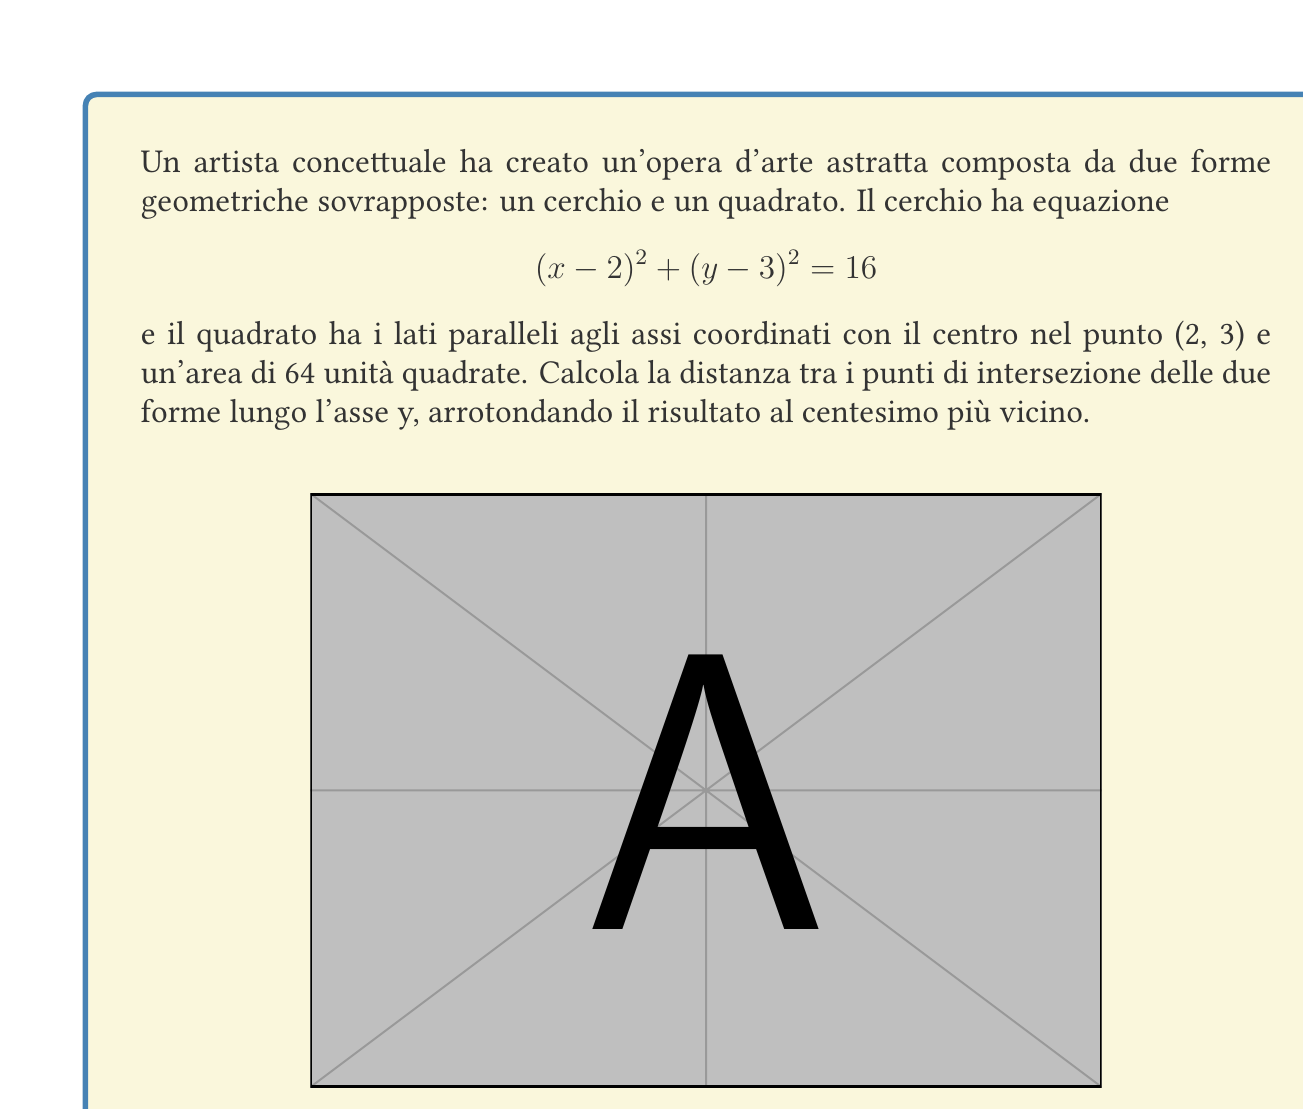What is the answer to this math problem? Per risolvere questo problema, seguiamo questi passaggi:

1) Troviamo l'equazione del quadrato:
   Il centro è (2,3) e l'area è 64. Il lato del quadrato è quindi $\sqrt{64} = 8$.
   Le equazioni dei lati verticali sono $x = 2 - 4$ e $x = 2 + 4$, cioè $x = -2$ e $x = 6$.

2) Per trovare i punti di intersezione, sostituiamo $x = 2$ (l'asse verticale che passa per il centro) nell'equazione del cerchio:

   $$(2-2)^2 + (y-3)^2 = 16$$
   $$(y-3)^2 = 16$$
   $$y-3 = \pm 4$$
   $$y = 3 \pm 4$$

3) Quindi, i punti di intersezione sull'asse y sono:
   $(2, 7)$ e $(2, -1)$

4) La distanza tra questi punti è:
   $$7 - (-1) = 8$$

Questo risultato mostra la simmetria perfetta dell'opera, con il cerchio e il quadrato perfettamente allineati e centrati nello stesso punto.
Answer: 8 unità 